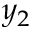<formula> <loc_0><loc_0><loc_500><loc_500>y _ { 2 }</formula> 